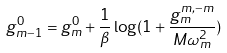Convert formula to latex. <formula><loc_0><loc_0><loc_500><loc_500>g _ { m - 1 } ^ { 0 } = g _ { m } ^ { 0 } + \frac { 1 } { \beta } \log ( 1 + \frac { g _ { m } ^ { m , - m } } { M \omega _ { m } ^ { 2 } } )</formula> 